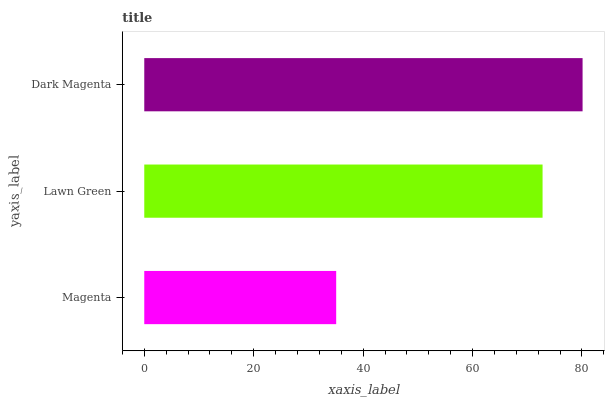Is Magenta the minimum?
Answer yes or no. Yes. Is Dark Magenta the maximum?
Answer yes or no. Yes. Is Lawn Green the minimum?
Answer yes or no. No. Is Lawn Green the maximum?
Answer yes or no. No. Is Lawn Green greater than Magenta?
Answer yes or no. Yes. Is Magenta less than Lawn Green?
Answer yes or no. Yes. Is Magenta greater than Lawn Green?
Answer yes or no. No. Is Lawn Green less than Magenta?
Answer yes or no. No. Is Lawn Green the high median?
Answer yes or no. Yes. Is Lawn Green the low median?
Answer yes or no. Yes. Is Dark Magenta the high median?
Answer yes or no. No. Is Magenta the low median?
Answer yes or no. No. 